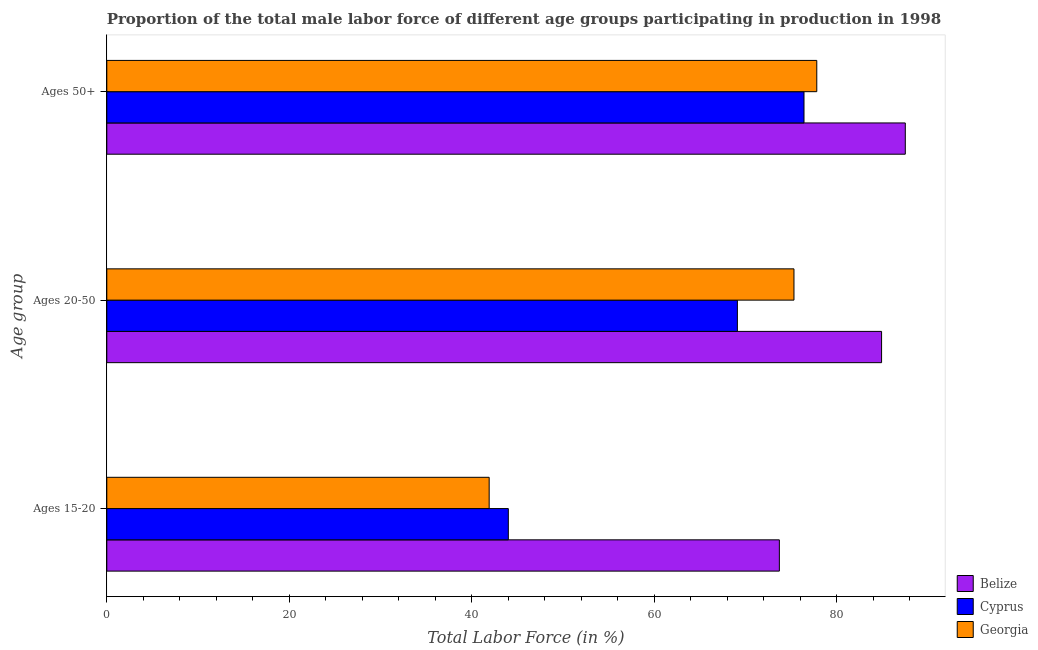Are the number of bars per tick equal to the number of legend labels?
Your response must be concise. Yes. Are the number of bars on each tick of the Y-axis equal?
Provide a short and direct response. Yes. How many bars are there on the 1st tick from the top?
Keep it short and to the point. 3. How many bars are there on the 2nd tick from the bottom?
Your answer should be compact. 3. What is the label of the 2nd group of bars from the top?
Give a very brief answer. Ages 20-50. What is the percentage of male labor force above age 50 in Cyprus?
Offer a terse response. 76.4. Across all countries, what is the maximum percentage of male labor force above age 50?
Your answer should be very brief. 87.5. Across all countries, what is the minimum percentage of male labor force within the age group 15-20?
Give a very brief answer. 41.9. In which country was the percentage of male labor force within the age group 15-20 maximum?
Your answer should be very brief. Belize. In which country was the percentage of male labor force above age 50 minimum?
Ensure brevity in your answer.  Cyprus. What is the total percentage of male labor force within the age group 20-50 in the graph?
Keep it short and to the point. 229.3. What is the difference between the percentage of male labor force within the age group 20-50 in Belize and that in Cyprus?
Your response must be concise. 15.8. What is the difference between the percentage of male labor force within the age group 20-50 in Georgia and the percentage of male labor force above age 50 in Cyprus?
Your response must be concise. -1.1. What is the average percentage of male labor force within the age group 20-50 per country?
Your response must be concise. 76.43. What is the difference between the percentage of male labor force above age 50 and percentage of male labor force within the age group 20-50 in Belize?
Provide a succinct answer. 2.6. In how many countries, is the percentage of male labor force within the age group 15-20 greater than 20 %?
Provide a short and direct response. 3. What is the ratio of the percentage of male labor force within the age group 15-20 in Cyprus to that in Georgia?
Ensure brevity in your answer.  1.05. What is the difference between the highest and the second highest percentage of male labor force within the age group 15-20?
Your response must be concise. 29.7. What is the difference between the highest and the lowest percentage of male labor force within the age group 20-50?
Provide a succinct answer. 15.8. What does the 2nd bar from the top in Ages 50+ represents?
Your answer should be very brief. Cyprus. What does the 2nd bar from the bottom in Ages 50+ represents?
Provide a short and direct response. Cyprus. What is the difference between two consecutive major ticks on the X-axis?
Your response must be concise. 20. Are the values on the major ticks of X-axis written in scientific E-notation?
Offer a very short reply. No. Does the graph contain any zero values?
Give a very brief answer. No. How are the legend labels stacked?
Your answer should be very brief. Vertical. What is the title of the graph?
Your answer should be very brief. Proportion of the total male labor force of different age groups participating in production in 1998. Does "Mongolia" appear as one of the legend labels in the graph?
Offer a very short reply. No. What is the label or title of the Y-axis?
Offer a very short reply. Age group. What is the Total Labor Force (in %) in Belize in Ages 15-20?
Offer a terse response. 73.7. What is the Total Labor Force (in %) of Georgia in Ages 15-20?
Give a very brief answer. 41.9. What is the Total Labor Force (in %) of Belize in Ages 20-50?
Provide a succinct answer. 84.9. What is the Total Labor Force (in %) in Cyprus in Ages 20-50?
Offer a very short reply. 69.1. What is the Total Labor Force (in %) in Georgia in Ages 20-50?
Keep it short and to the point. 75.3. What is the Total Labor Force (in %) of Belize in Ages 50+?
Ensure brevity in your answer.  87.5. What is the Total Labor Force (in %) in Cyprus in Ages 50+?
Keep it short and to the point. 76.4. What is the Total Labor Force (in %) in Georgia in Ages 50+?
Your response must be concise. 77.8. Across all Age group, what is the maximum Total Labor Force (in %) in Belize?
Keep it short and to the point. 87.5. Across all Age group, what is the maximum Total Labor Force (in %) in Cyprus?
Your answer should be compact. 76.4. Across all Age group, what is the maximum Total Labor Force (in %) of Georgia?
Your response must be concise. 77.8. Across all Age group, what is the minimum Total Labor Force (in %) of Belize?
Make the answer very short. 73.7. Across all Age group, what is the minimum Total Labor Force (in %) of Georgia?
Provide a short and direct response. 41.9. What is the total Total Labor Force (in %) in Belize in the graph?
Ensure brevity in your answer.  246.1. What is the total Total Labor Force (in %) of Cyprus in the graph?
Keep it short and to the point. 189.5. What is the total Total Labor Force (in %) of Georgia in the graph?
Offer a terse response. 195. What is the difference between the Total Labor Force (in %) in Cyprus in Ages 15-20 and that in Ages 20-50?
Make the answer very short. -25.1. What is the difference between the Total Labor Force (in %) in Georgia in Ages 15-20 and that in Ages 20-50?
Ensure brevity in your answer.  -33.4. What is the difference between the Total Labor Force (in %) of Belize in Ages 15-20 and that in Ages 50+?
Offer a very short reply. -13.8. What is the difference between the Total Labor Force (in %) of Cyprus in Ages 15-20 and that in Ages 50+?
Offer a terse response. -32.4. What is the difference between the Total Labor Force (in %) of Georgia in Ages 15-20 and that in Ages 50+?
Make the answer very short. -35.9. What is the difference between the Total Labor Force (in %) in Belize in Ages 15-20 and the Total Labor Force (in %) in Cyprus in Ages 20-50?
Make the answer very short. 4.6. What is the difference between the Total Labor Force (in %) in Cyprus in Ages 15-20 and the Total Labor Force (in %) in Georgia in Ages 20-50?
Your answer should be very brief. -31.3. What is the difference between the Total Labor Force (in %) in Belize in Ages 15-20 and the Total Labor Force (in %) in Cyprus in Ages 50+?
Your response must be concise. -2.7. What is the difference between the Total Labor Force (in %) of Cyprus in Ages 15-20 and the Total Labor Force (in %) of Georgia in Ages 50+?
Make the answer very short. -33.8. What is the difference between the Total Labor Force (in %) in Belize in Ages 20-50 and the Total Labor Force (in %) in Georgia in Ages 50+?
Make the answer very short. 7.1. What is the difference between the Total Labor Force (in %) of Cyprus in Ages 20-50 and the Total Labor Force (in %) of Georgia in Ages 50+?
Your answer should be very brief. -8.7. What is the average Total Labor Force (in %) of Belize per Age group?
Your response must be concise. 82.03. What is the average Total Labor Force (in %) in Cyprus per Age group?
Offer a very short reply. 63.17. What is the difference between the Total Labor Force (in %) in Belize and Total Labor Force (in %) in Cyprus in Ages 15-20?
Ensure brevity in your answer.  29.7. What is the difference between the Total Labor Force (in %) of Belize and Total Labor Force (in %) of Georgia in Ages 15-20?
Provide a succinct answer. 31.8. What is the difference between the Total Labor Force (in %) of Belize and Total Labor Force (in %) of Cyprus in Ages 20-50?
Give a very brief answer. 15.8. What is the difference between the Total Labor Force (in %) of Belize and Total Labor Force (in %) of Cyprus in Ages 50+?
Your answer should be very brief. 11.1. What is the difference between the Total Labor Force (in %) of Cyprus and Total Labor Force (in %) of Georgia in Ages 50+?
Your answer should be very brief. -1.4. What is the ratio of the Total Labor Force (in %) of Belize in Ages 15-20 to that in Ages 20-50?
Your response must be concise. 0.87. What is the ratio of the Total Labor Force (in %) in Cyprus in Ages 15-20 to that in Ages 20-50?
Offer a terse response. 0.64. What is the ratio of the Total Labor Force (in %) of Georgia in Ages 15-20 to that in Ages 20-50?
Make the answer very short. 0.56. What is the ratio of the Total Labor Force (in %) in Belize in Ages 15-20 to that in Ages 50+?
Your response must be concise. 0.84. What is the ratio of the Total Labor Force (in %) of Cyprus in Ages 15-20 to that in Ages 50+?
Ensure brevity in your answer.  0.58. What is the ratio of the Total Labor Force (in %) in Georgia in Ages 15-20 to that in Ages 50+?
Keep it short and to the point. 0.54. What is the ratio of the Total Labor Force (in %) in Belize in Ages 20-50 to that in Ages 50+?
Your response must be concise. 0.97. What is the ratio of the Total Labor Force (in %) in Cyprus in Ages 20-50 to that in Ages 50+?
Your response must be concise. 0.9. What is the ratio of the Total Labor Force (in %) in Georgia in Ages 20-50 to that in Ages 50+?
Offer a terse response. 0.97. What is the difference between the highest and the second highest Total Labor Force (in %) of Cyprus?
Ensure brevity in your answer.  7.3. What is the difference between the highest and the lowest Total Labor Force (in %) of Cyprus?
Your answer should be very brief. 32.4. What is the difference between the highest and the lowest Total Labor Force (in %) of Georgia?
Offer a very short reply. 35.9. 